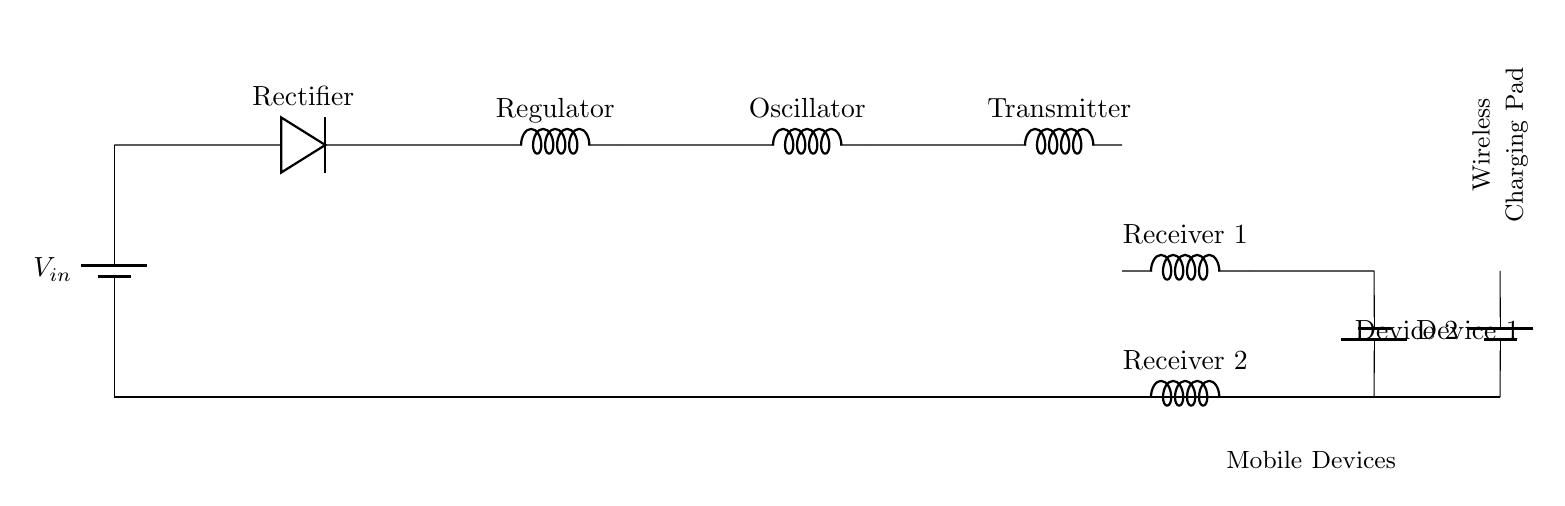What is the input voltage of the circuit? The input voltage is indicated by the label on the battery component, which is V_in. The exact value isn't specified, but it is usually assumed to be standard voltage levels like 5V or 12V.
Answer: V_in How many receiver coils are present? The diagram shows two receiver coils, labeled as Receiver 1 and Receiver 2. They are distinctly separated within the circuit layout.
Answer: 2 What is the function of the oscillator in this circuit? The oscillator is responsible for generating a high-frequency alternating current that enables efficient wireless power transmission. Its placement after the voltage regulator further confirms this.
Answer: Generate AC What component converts AC to DC? The rectifier, represented by the diode symbol, is responsible for converting the alternating current from the oscillator output to direct current for use by the devices.
Answer: Rectifier How is the wireless charging pad labeled? The wireless charging pad is labeled with a text node near the top of the circuit diagram, which indicates its primary function.
Answer: Wireless Charging Pad What do the cute inductors represent? The cute inductors indicate various functions in the circuit, namely as a voltage regulator, oscillator, transmitter, and receiver coils, which are essential for the wireless charging mechanism.
Answer: Inductors Which devices are powered by this circuit? The circuit indicates two mobile devices connected to the receiver coils via battery symbols, specifically labeled as Device 1 and Device 2.
Answer: Device 1 and Device 2 